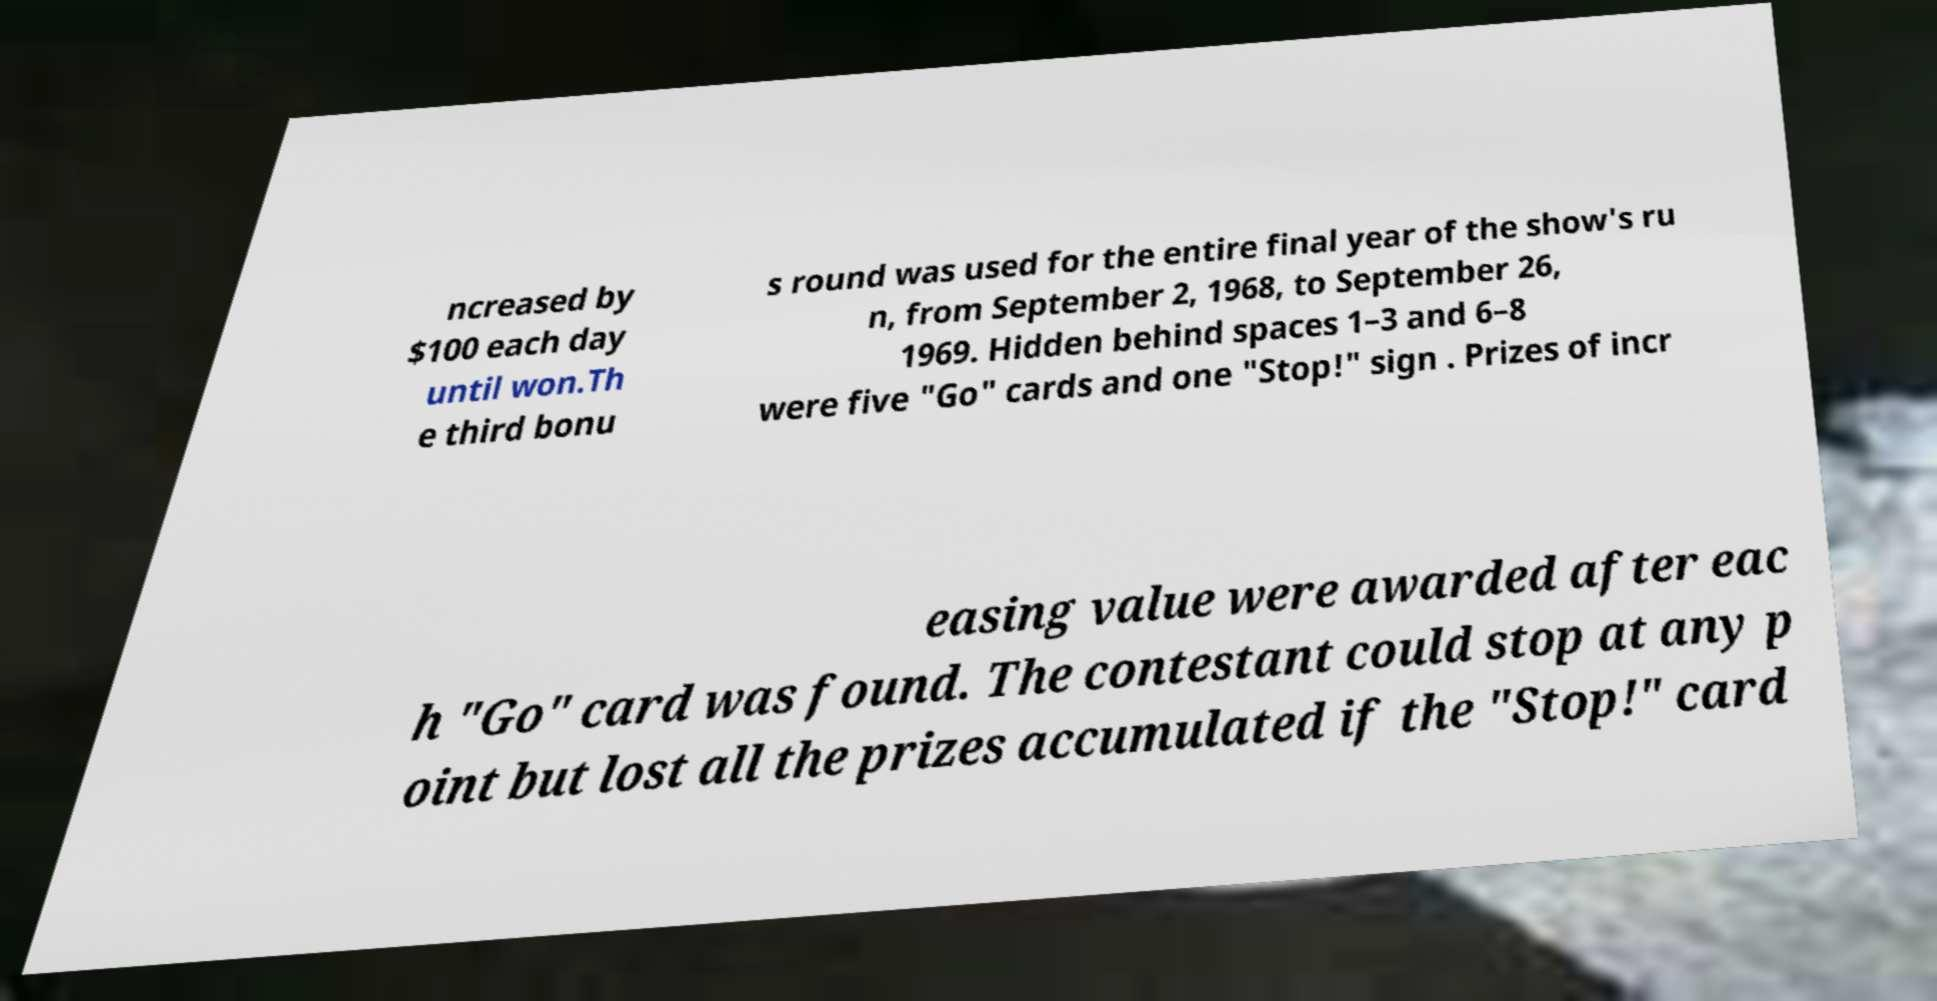Can you accurately transcribe the text from the provided image for me? ncreased by $100 each day until won.Th e third bonu s round was used for the entire final year of the show's ru n, from September 2, 1968, to September 26, 1969. Hidden behind spaces 1–3 and 6–8 were five "Go" cards and one "Stop!" sign . Prizes of incr easing value were awarded after eac h "Go" card was found. The contestant could stop at any p oint but lost all the prizes accumulated if the "Stop!" card 